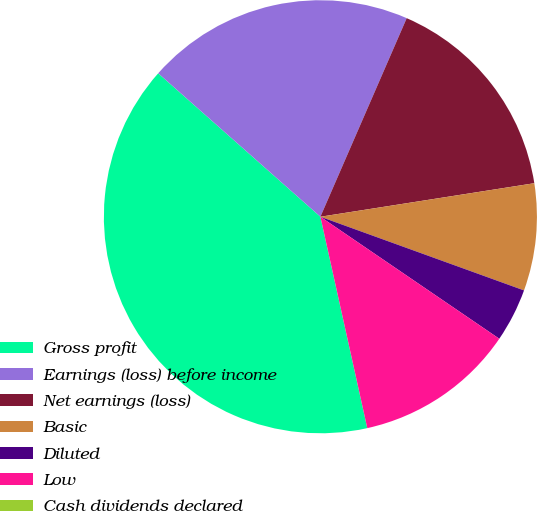Convert chart. <chart><loc_0><loc_0><loc_500><loc_500><pie_chart><fcel>Gross profit<fcel>Earnings (loss) before income<fcel>Net earnings (loss)<fcel>Basic<fcel>Diluted<fcel>Low<fcel>Cash dividends declared<nl><fcel>40.0%<fcel>20.0%<fcel>16.0%<fcel>8.0%<fcel>4.0%<fcel>12.0%<fcel>0.0%<nl></chart> 